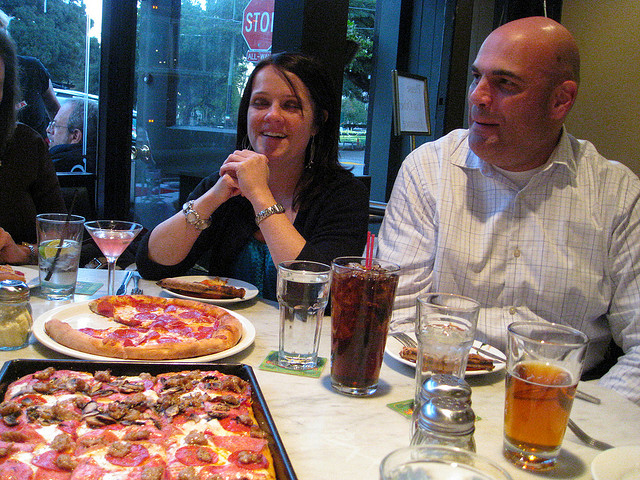Can you describe the setting of this meal? The meal takes place in a cozy indoor setting with a large window beside the table, giving a view of the outside street. The ambiance suggests a casual dining atmosphere, perfect for enjoying a meal with companions.  What kind of beverages are the people having? In the image, there are several types of beverages. There's a soft drink, which could be cola, in a tall glass with ice, a pint of amber-colored beer, and another with a clear cocktail, perhaps containing ice and lime, suggesting a refreshing mix suitable for a variety of tastes. 